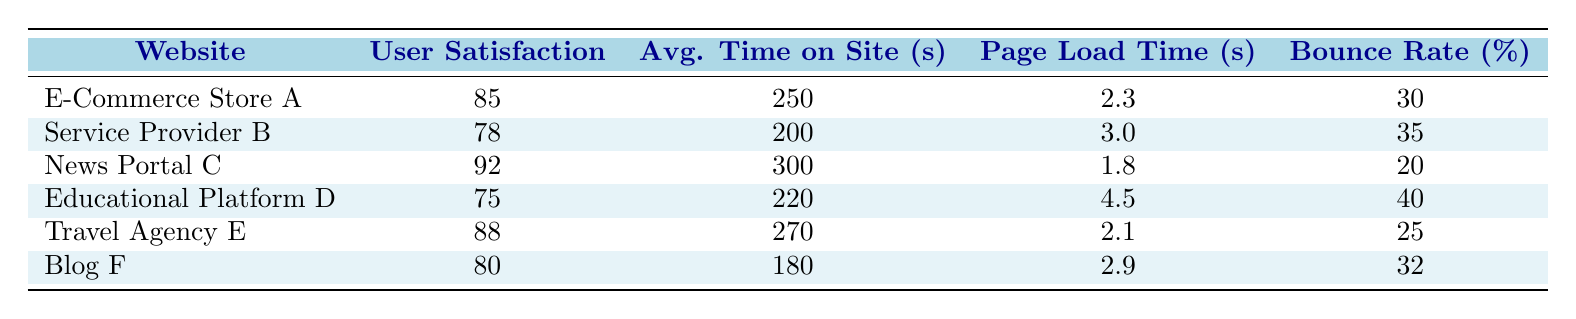What is the user satisfaction score for News Portal C? From the table, the row corresponding to News Portal C shows a user satisfaction score of 92.
Answer: 92 Which website has the lowest bounce rate? By examining the Bounce Rate column, the lowest percentage is 20%, which corresponds to News Portal C.
Answer: News Portal C What is the average user satisfaction score of all websites listed? Add the user satisfaction scores: 85 + 78 + 92 + 75 + 88 + 80 = 498. There are 6 websites, so the average is 498/6 = 83.
Answer: 83 Is the average time on site for Travel Agency E greater than that of Blog F? The average time on site for Travel Agency E is 270 seconds, while for Blog F, it is 180 seconds. Therefore, yes, Travel Agency E has a higher average time on site.
Answer: Yes What is the difference in user satisfaction scores between E-Commerce Store A and Educational Platform D? The user satisfaction score for E-Commerce Store A is 85 and for Educational Platform D, it is 75. The difference is 85 - 75 = 10.
Answer: 10 Which website achieved a user satisfaction score of 80 or higher? The websites with scores of 80 or higher are E-Commerce Store A (85), Travel Agency E (88), and News Portal C (92).
Answer: E-Commerce Store A, Travel Agency E, News Portal C What is the average page load time of all the websites? The page load times are 2.3, 3.0, 1.8, 4.5, 2.1, and 2.9 seconds. Adding these gives 16.6 seconds total, and dividing by 6 gives an average of 16.6/6 = 2.77 seconds.
Answer: 2.77 seconds Is the user satisfaction score for Service Provider B above the average satisfaction score of the listed websites? The average user satisfaction score, calculated as 83, is above Service Provider B’s score of 78. Thus, no, it is not above average.
Answer: No Which website has the highest average time on site? Looking through the table, News Portal C has the highest average time on site at 300 seconds.
Answer: News Portal C 